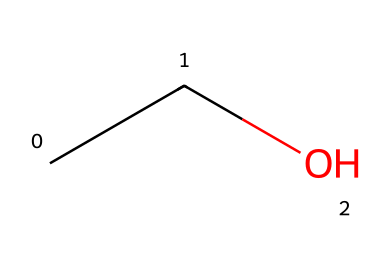How many carbon atoms are present in this molecule? Looking at the SMILES representation "CCO," we can see there are two "C" characters, which represent carbon atoms. Thus, the molecule consists of two carbon atoms.
Answer: two What is the molecular name of this compound? The SMILES "CCO" corresponds to ethanol, which is commonly known as ethyl alcohol. This is confirmed by the presence of two carbon atoms and an -OH group at the end.
Answer: ethanol How many hydrogen atoms are in this molecule? To determine the number of hydrogen atoms, we can apply the general formula for alcohols, which is CnH2n+1OH. For n=2, this gives us 5 hydrogen atoms (2*2 + 1 + 1 = 5).
Answer: five What type of functional group is present in this chemical? The "OH" (hydroxyl) group at the end of the SMILES structure indicates the presence of an alcohol functional group. Therefore, the molecule has a hydroxyl functional group.
Answer: hydroxyl Is this compound considered a hydrocarbon? Although this molecule contains carbon and hydrogen atoms, the presence of the hydroxyl group (OH) classifies it as an alcohol, not a pure hydrocarbon. Therefore, it does not meet the strict definition of a hydrocarbon.
Answer: no What type of bond is present between C and O? The bonding situation can be deduced from the structure: the bond between the carbon (C) and oxygen (O) in the hydroxyl group is a single covalent bond, which means they share one pair of electrons.
Answer: single covalent 